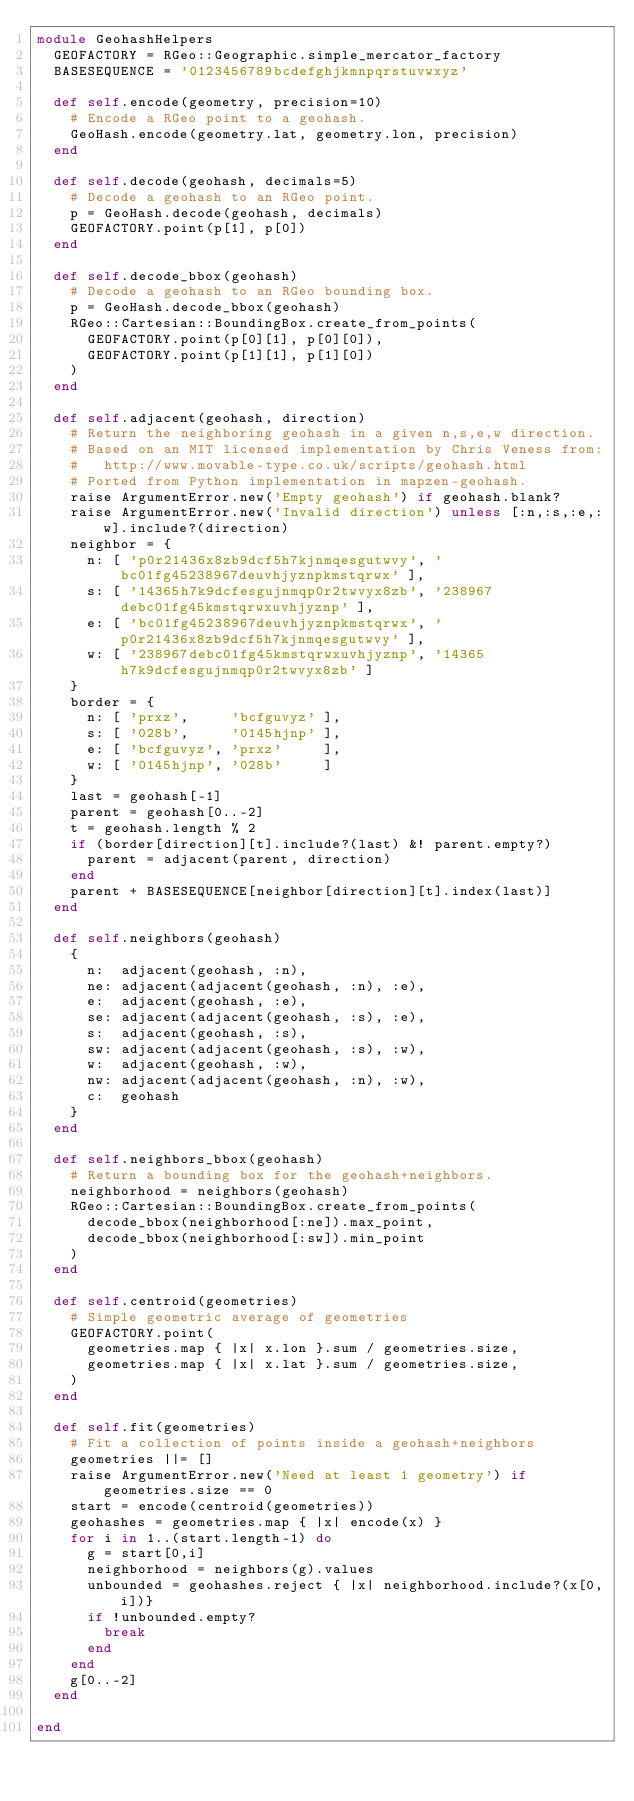<code> <loc_0><loc_0><loc_500><loc_500><_Ruby_>module GeohashHelpers
  GEOFACTORY = RGeo::Geographic.simple_mercator_factory
  BASESEQUENCE = '0123456789bcdefghjkmnpqrstuvwxyz'

  def self.encode(geometry, precision=10)
    # Encode a RGeo point to a geohash.
    GeoHash.encode(geometry.lat, geometry.lon, precision)
  end

  def self.decode(geohash, decimals=5)
    # Decode a geohash to an RGeo point.
    p = GeoHash.decode(geohash, decimals)
    GEOFACTORY.point(p[1], p[0])
  end

  def self.decode_bbox(geohash)
    # Decode a geohash to an RGeo bounding box.
    p = GeoHash.decode_bbox(geohash)
    RGeo::Cartesian::BoundingBox.create_from_points(
      GEOFACTORY.point(p[0][1], p[0][0]),
      GEOFACTORY.point(p[1][1], p[1][0])
    )
  end

  def self.adjacent(geohash, direction)
    # Return the neighboring geohash in a given n,s,e,w direction.
    # Based on an MIT licensed implementation by Chris Veness from:
    #   http://www.movable-type.co.uk/scripts/geohash.html
    # Ported from Python implementation in mapzen-geohash.
    raise ArgumentError.new('Empty geohash') if geohash.blank?
    raise ArgumentError.new('Invalid direction') unless [:n,:s,:e,:w].include?(direction)
    neighbor = {
      n: [ 'p0r21436x8zb9dcf5h7kjnmqesgutwvy', 'bc01fg45238967deuvhjyznpkmstqrwx' ],
      s: [ '14365h7k9dcfesgujnmqp0r2twvyx8zb', '238967debc01fg45kmstqrwxuvhjyznp' ],
      e: [ 'bc01fg45238967deuvhjyznpkmstqrwx', 'p0r21436x8zb9dcf5h7kjnmqesgutwvy' ],
      w: [ '238967debc01fg45kmstqrwxuvhjyznp', '14365h7k9dcfesgujnmqp0r2twvyx8zb' ]
    }
    border = {
      n: [ 'prxz',     'bcfguvyz' ],
      s: [ '028b',     '0145hjnp' ],
      e: [ 'bcfguvyz', 'prxz'     ],
      w: [ '0145hjnp', '028b'     ]
    }
    last = geohash[-1]
    parent = geohash[0..-2]
    t = geohash.length % 2
    if (border[direction][t].include?(last) &! parent.empty?)
      parent = adjacent(parent, direction)
    end
    parent + BASESEQUENCE[neighbor[direction][t].index(last)]
  end

  def self.neighbors(geohash)
    {
      n:  adjacent(geohash, :n),
      ne: adjacent(adjacent(geohash, :n), :e),
      e:  adjacent(geohash, :e),
      se: adjacent(adjacent(geohash, :s), :e),
      s:  adjacent(geohash, :s),
      sw: adjacent(adjacent(geohash, :s), :w),
      w:  adjacent(geohash, :w),
      nw: adjacent(adjacent(geohash, :n), :w),
      c:  geohash
    }
  end

  def self.neighbors_bbox(geohash)
    # Return a bounding box for the geohash+neighbors.
    neighborhood = neighbors(geohash)
    RGeo::Cartesian::BoundingBox.create_from_points(
      decode_bbox(neighborhood[:ne]).max_point,
      decode_bbox(neighborhood[:sw]).min_point
    )
  end

  def self.centroid(geometries)
    # Simple geometric average of geometries
    GEOFACTORY.point(
      geometries.map { |x| x.lon }.sum / geometries.size,
      geometries.map { |x| x.lat }.sum / geometries.size,
    )
  end

  def self.fit(geometries)
    # Fit a collection of points inside a geohash+neighbors
    geometries ||= []
    raise ArgumentError.new('Need at least 1 geometry') if geometries.size == 0
    start = encode(centroid(geometries))
    geohashes = geometries.map { |x| encode(x) }
    for i in 1..(start.length-1) do
      g = start[0,i]
      neighborhood = neighbors(g).values
      unbounded = geohashes.reject { |x| neighborhood.include?(x[0,i])}
      if !unbounded.empty?
        break
      end
    end
    g[0..-2]
  end

end
</code> 